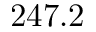Convert formula to latex. <formula><loc_0><loc_0><loc_500><loc_500>2 4 7 . 2</formula> 